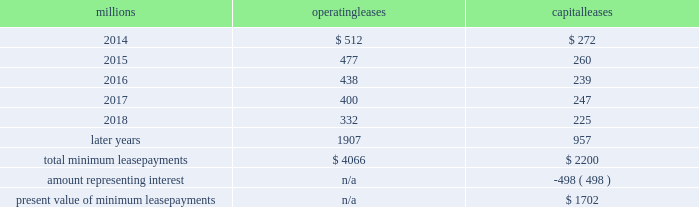On december 19 , 2011 , we redeemed the remaining $ 175 million of our 6.5% ( 6.5 % ) notes due april 15 , 2012 , and all $ 300 million of our outstanding 6.125% ( 6.125 % ) notes due january 15 , 2012 .
The redemptions resulted in an early extinguishment charge of $ 5 million in the fourth quarter of 2011 .
Receivables securitization facility 2013 as of december 31 , 2013 and 2012 , we recorded $ 0 and $ 100 million , respectively , as secured debt under our receivables securitization facility .
( see further discussion of our receivables securitization facility in note 10 ) .
15 .
Variable interest entities we have entered into various lease transactions in which the structure of the leases contain variable interest entities ( vies ) .
These vies were created solely for the purpose of doing lease transactions ( principally involving railroad equipment and facilities , including our headquarters building ) and have no other activities , assets or liabilities outside of the lease transactions .
Within these lease arrangements , we have the right to purchase some or all of the assets at fixed prices .
Depending on market conditions , fixed-price purchase options available in the leases could potentially provide benefits to us ; however , these benefits are not expected to be significant .
We maintain and operate the assets based on contractual obligations within the lease arrangements , which set specific guidelines consistent within the railroad industry .
As such , we have no control over activities that could materially impact the fair value of the leased assets .
We do not hold the power to direct the activities of the vies and , therefore , do not control the ongoing activities that have a significant impact on the economic performance of the vies .
Additionally , we do not have the obligation to absorb losses of the vies or the right to receive benefits of the vies that could potentially be significant to the we are not considered to be the primary beneficiary and do not consolidate these vies because our actions and decisions do not have the most significant effect on the vie 2019s performance and our fixed-price purchase price options are not considered to be potentially significant to the vies .
The future minimum lease payments associated with the vie leases totaled $ 3.3 billion as of december 31 , 2013 .
16 .
Leases we lease certain locomotives , freight cars , and other property .
The consolidated statements of financial position as of december 31 , 2013 and 2012 included $ 2486 million , net of $ 1092 million of accumulated depreciation , and $ 2467 million , net of $ 966 million of accumulated depreciation , respectively , for properties held under capital leases .
A charge to income resulting from the depreciation for assets held under capital leases is included within depreciation expense in our consolidated statements of income .
Future minimum lease payments for operating and capital leases with initial or remaining non-cancelable lease terms in excess of one year as of december 31 , 2013 , were as follows : millions operating leases capital leases .
Approximately 94% ( 94 % ) of capital lease payments relate to locomotives .
Rent expense for operating leases with terms exceeding one month was $ 618 million in 2013 , $ 631 million in 2012 , and $ 637 million in 2011 .
When cash rental payments are not made on a straight-line basis , we recognize variable rental expense on a straight-line basis over the lease term .
Contingent rentals and sub-rentals are not significant. .
As of december 31 , 2013 what was the percent of the capital lease payments related to locomotives in millions? 
Computations: (2200 * 94%)
Answer: 2068.0. On december 19 , 2011 , we redeemed the remaining $ 175 million of our 6.5% ( 6.5 % ) notes due april 15 , 2012 , and all $ 300 million of our outstanding 6.125% ( 6.125 % ) notes due january 15 , 2012 .
The redemptions resulted in an early extinguishment charge of $ 5 million in the fourth quarter of 2011 .
Receivables securitization facility 2013 as of december 31 , 2013 and 2012 , we recorded $ 0 and $ 100 million , respectively , as secured debt under our receivables securitization facility .
( see further discussion of our receivables securitization facility in note 10 ) .
15 .
Variable interest entities we have entered into various lease transactions in which the structure of the leases contain variable interest entities ( vies ) .
These vies were created solely for the purpose of doing lease transactions ( principally involving railroad equipment and facilities , including our headquarters building ) and have no other activities , assets or liabilities outside of the lease transactions .
Within these lease arrangements , we have the right to purchase some or all of the assets at fixed prices .
Depending on market conditions , fixed-price purchase options available in the leases could potentially provide benefits to us ; however , these benefits are not expected to be significant .
We maintain and operate the assets based on contractual obligations within the lease arrangements , which set specific guidelines consistent within the railroad industry .
As such , we have no control over activities that could materially impact the fair value of the leased assets .
We do not hold the power to direct the activities of the vies and , therefore , do not control the ongoing activities that have a significant impact on the economic performance of the vies .
Additionally , we do not have the obligation to absorb losses of the vies or the right to receive benefits of the vies that could potentially be significant to the we are not considered to be the primary beneficiary and do not consolidate these vies because our actions and decisions do not have the most significant effect on the vie 2019s performance and our fixed-price purchase price options are not considered to be potentially significant to the vies .
The future minimum lease payments associated with the vie leases totaled $ 3.3 billion as of december 31 , 2013 .
16 .
Leases we lease certain locomotives , freight cars , and other property .
The consolidated statements of financial position as of december 31 , 2013 and 2012 included $ 2486 million , net of $ 1092 million of accumulated depreciation , and $ 2467 million , net of $ 966 million of accumulated depreciation , respectively , for properties held under capital leases .
A charge to income resulting from the depreciation for assets held under capital leases is included within depreciation expense in our consolidated statements of income .
Future minimum lease payments for operating and capital leases with initial or remaining non-cancelable lease terms in excess of one year as of december 31 , 2013 , were as follows : millions operating leases capital leases .
Approximately 94% ( 94 % ) of capital lease payments relate to locomotives .
Rent expense for operating leases with terms exceeding one month was $ 618 million in 2013 , $ 631 million in 2012 , and $ 637 million in 2011 .
When cash rental payments are not made on a straight-line basis , we recognize variable rental expense on a straight-line basis over the lease term .
Contingent rentals and sub-rentals are not significant. .
As of december 31 , 2013 what was the percent of the total operating non-cancelable lease terms in excess of one year due in 2015? 
Computations: (477 / 4066)
Answer: 0.11731. 